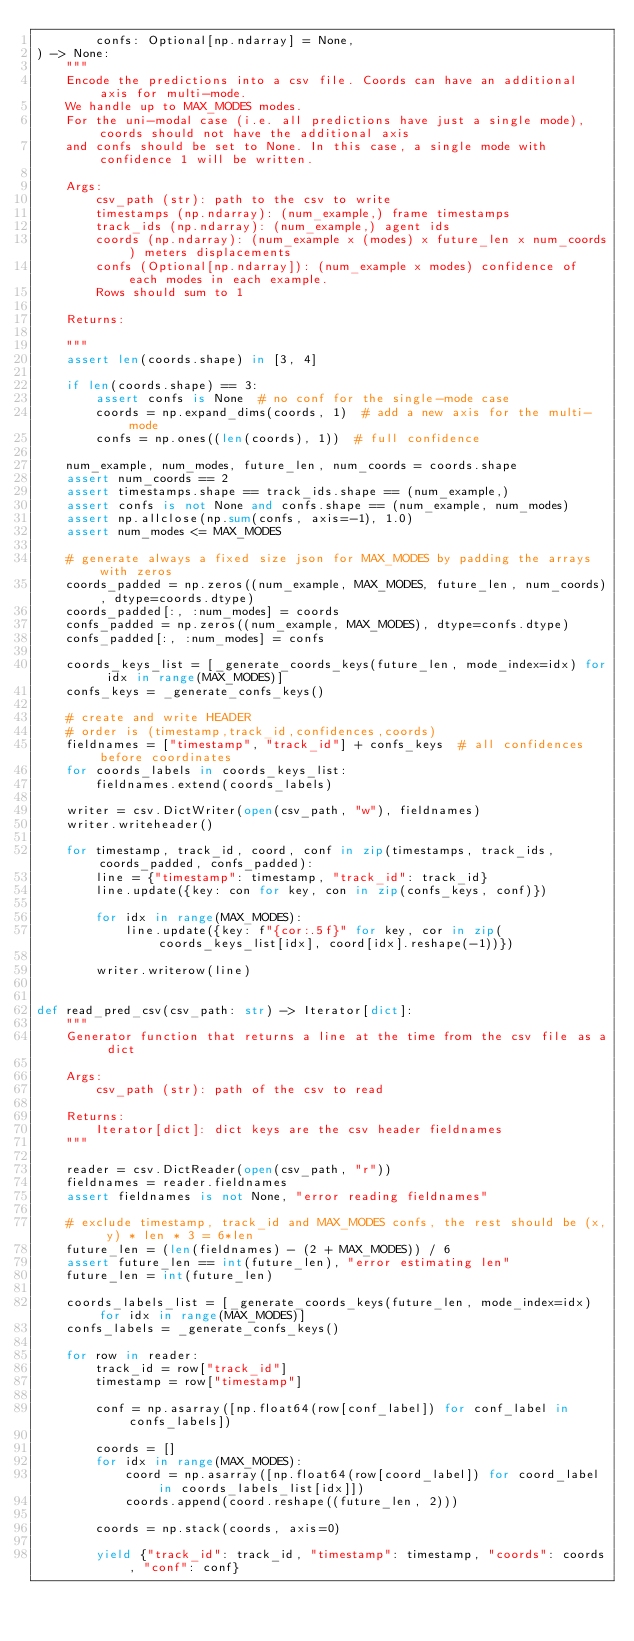<code> <loc_0><loc_0><loc_500><loc_500><_Python_>        confs: Optional[np.ndarray] = None,
) -> None:
    """
    Encode the predictions into a csv file. Coords can have an additional axis for multi-mode.
    We handle up to MAX_MODES modes.
    For the uni-modal case (i.e. all predictions have just a single mode), coords should not have the additional axis
    and confs should be set to None. In this case, a single mode with confidence 1 will be written.

    Args:
        csv_path (str): path to the csv to write
        timestamps (np.ndarray): (num_example,) frame timestamps
        track_ids (np.ndarray): (num_example,) agent ids
        coords (np.ndarray): (num_example x (modes) x future_len x num_coords) meters displacements
        confs (Optional[np.ndarray]): (num_example x modes) confidence of each modes in each example.
        Rows should sum to 1

    Returns:

    """
    assert len(coords.shape) in [3, 4]

    if len(coords.shape) == 3:
        assert confs is None  # no conf for the single-mode case
        coords = np.expand_dims(coords, 1)  # add a new axis for the multi-mode
        confs = np.ones((len(coords), 1))  # full confidence

    num_example, num_modes, future_len, num_coords = coords.shape
    assert num_coords == 2
    assert timestamps.shape == track_ids.shape == (num_example,)
    assert confs is not None and confs.shape == (num_example, num_modes)
    assert np.allclose(np.sum(confs, axis=-1), 1.0)
    assert num_modes <= MAX_MODES

    # generate always a fixed size json for MAX_MODES by padding the arrays with zeros
    coords_padded = np.zeros((num_example, MAX_MODES, future_len, num_coords), dtype=coords.dtype)
    coords_padded[:, :num_modes] = coords
    confs_padded = np.zeros((num_example, MAX_MODES), dtype=confs.dtype)
    confs_padded[:, :num_modes] = confs

    coords_keys_list = [_generate_coords_keys(future_len, mode_index=idx) for idx in range(MAX_MODES)]
    confs_keys = _generate_confs_keys()

    # create and write HEADER
    # order is (timestamp,track_id,confidences,coords)
    fieldnames = ["timestamp", "track_id"] + confs_keys  # all confidences before coordinates
    for coords_labels in coords_keys_list:
        fieldnames.extend(coords_labels)

    writer = csv.DictWriter(open(csv_path, "w"), fieldnames)
    writer.writeheader()

    for timestamp, track_id, coord, conf in zip(timestamps, track_ids, coords_padded, confs_padded):
        line = {"timestamp": timestamp, "track_id": track_id}
        line.update({key: con for key, con in zip(confs_keys, conf)})

        for idx in range(MAX_MODES):
            line.update({key: f"{cor:.5f}" for key, cor in zip(coords_keys_list[idx], coord[idx].reshape(-1))})

        writer.writerow(line)


def read_pred_csv(csv_path: str) -> Iterator[dict]:
    """
    Generator function that returns a line at the time from the csv file as a dict

    Args:
        csv_path (str): path of the csv to read

    Returns:
        Iterator[dict]: dict keys are the csv header fieldnames
    """

    reader = csv.DictReader(open(csv_path, "r"))
    fieldnames = reader.fieldnames
    assert fieldnames is not None, "error reading fieldnames"

    # exclude timestamp, track_id and MAX_MODES confs, the rest should be (x, y) * len * 3 = 6*len
    future_len = (len(fieldnames) - (2 + MAX_MODES)) / 6
    assert future_len == int(future_len), "error estimating len"
    future_len = int(future_len)

    coords_labels_list = [_generate_coords_keys(future_len, mode_index=idx) for idx in range(MAX_MODES)]
    confs_labels = _generate_confs_keys()

    for row in reader:
        track_id = row["track_id"]
        timestamp = row["timestamp"]

        conf = np.asarray([np.float64(row[conf_label]) for conf_label in confs_labels])

        coords = []
        for idx in range(MAX_MODES):
            coord = np.asarray([np.float64(row[coord_label]) for coord_label in coords_labels_list[idx]])
            coords.append(coord.reshape((future_len, 2)))

        coords = np.stack(coords, axis=0)

        yield {"track_id": track_id, "timestamp": timestamp, "coords": coords, "conf": conf}
</code> 